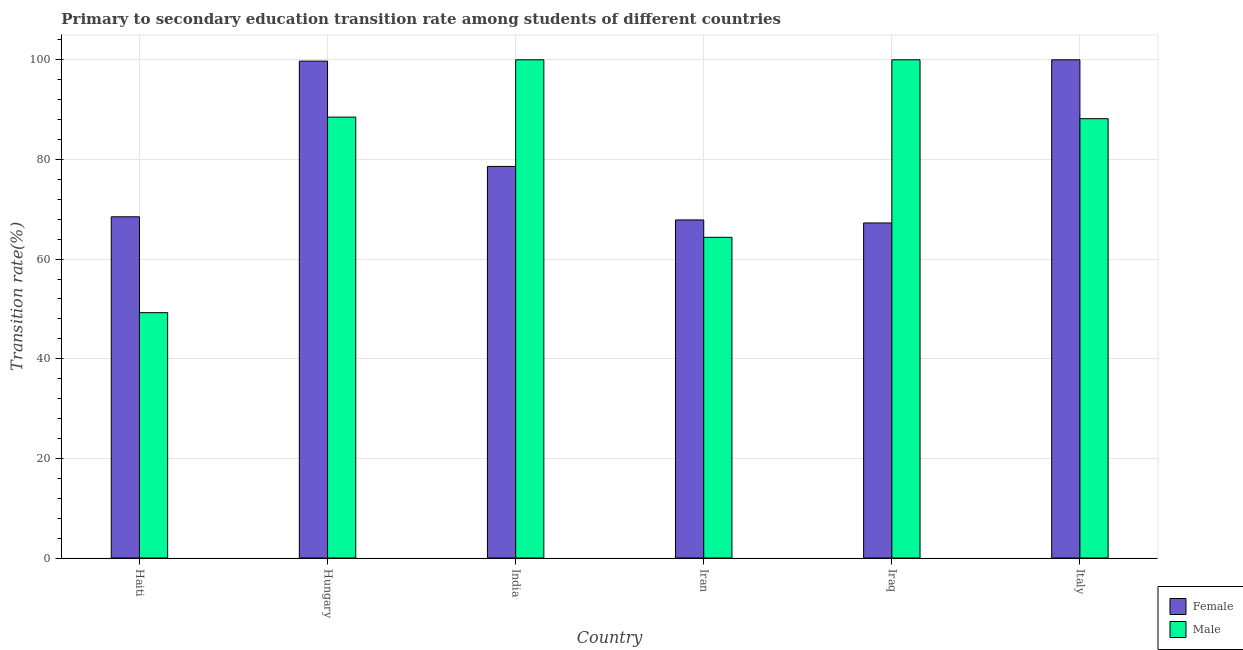How many different coloured bars are there?
Make the answer very short. 2. How many groups of bars are there?
Make the answer very short. 6. Are the number of bars per tick equal to the number of legend labels?
Your response must be concise. Yes. Are the number of bars on each tick of the X-axis equal?
Your response must be concise. Yes. What is the transition rate among male students in Hungary?
Offer a very short reply. 88.49. Across all countries, what is the minimum transition rate among male students?
Provide a short and direct response. 49.25. In which country was the transition rate among female students minimum?
Make the answer very short. Iraq. What is the total transition rate among male students in the graph?
Keep it short and to the point. 490.28. What is the difference between the transition rate among female students in Hungary and that in Iran?
Keep it short and to the point. 31.88. What is the difference between the transition rate among female students in Iran and the transition rate among male students in Italy?
Give a very brief answer. -20.32. What is the average transition rate among female students per country?
Give a very brief answer. 80.32. What is the difference between the transition rate among female students and transition rate among male students in Italy?
Provide a short and direct response. 11.82. What is the ratio of the transition rate among male students in Iran to that in Iraq?
Offer a terse response. 0.64. Is the transition rate among male students in Haiti less than that in Hungary?
Make the answer very short. Yes. Is the difference between the transition rate among male students in Haiti and India greater than the difference between the transition rate among female students in Haiti and India?
Provide a succinct answer. No. What is the difference between the highest and the second highest transition rate among female students?
Provide a short and direct response. 0.27. What is the difference between the highest and the lowest transition rate among female students?
Your answer should be compact. 32.75. In how many countries, is the transition rate among female students greater than the average transition rate among female students taken over all countries?
Offer a very short reply. 2. What does the 1st bar from the right in Iraq represents?
Provide a short and direct response. Male. How many bars are there?
Provide a succinct answer. 12. Are all the bars in the graph horizontal?
Your answer should be very brief. No. How many countries are there in the graph?
Give a very brief answer. 6. Does the graph contain any zero values?
Provide a short and direct response. No. Does the graph contain grids?
Provide a succinct answer. Yes. What is the title of the graph?
Ensure brevity in your answer.  Primary to secondary education transition rate among students of different countries. What is the label or title of the X-axis?
Your answer should be very brief. Country. What is the label or title of the Y-axis?
Offer a very short reply. Transition rate(%). What is the Transition rate(%) of Female in Haiti?
Provide a succinct answer. 68.48. What is the Transition rate(%) in Male in Haiti?
Keep it short and to the point. 49.25. What is the Transition rate(%) of Female in Hungary?
Offer a very short reply. 99.73. What is the Transition rate(%) of Male in Hungary?
Ensure brevity in your answer.  88.49. What is the Transition rate(%) in Female in India?
Your answer should be compact. 78.6. What is the Transition rate(%) of Male in India?
Ensure brevity in your answer.  100. What is the Transition rate(%) in Female in Iran?
Your answer should be very brief. 67.85. What is the Transition rate(%) of Male in Iran?
Give a very brief answer. 64.37. What is the Transition rate(%) of Female in Iraq?
Offer a very short reply. 67.25. What is the Transition rate(%) of Female in Italy?
Your response must be concise. 100. What is the Transition rate(%) in Male in Italy?
Ensure brevity in your answer.  88.18. Across all countries, what is the maximum Transition rate(%) of Female?
Keep it short and to the point. 100. Across all countries, what is the maximum Transition rate(%) in Male?
Provide a succinct answer. 100. Across all countries, what is the minimum Transition rate(%) in Female?
Keep it short and to the point. 67.25. Across all countries, what is the minimum Transition rate(%) of Male?
Your answer should be very brief. 49.25. What is the total Transition rate(%) of Female in the graph?
Provide a succinct answer. 481.91. What is the total Transition rate(%) in Male in the graph?
Offer a terse response. 490.28. What is the difference between the Transition rate(%) of Female in Haiti and that in Hungary?
Your answer should be compact. -31.24. What is the difference between the Transition rate(%) of Male in Haiti and that in Hungary?
Provide a succinct answer. -39.25. What is the difference between the Transition rate(%) of Female in Haiti and that in India?
Ensure brevity in your answer.  -10.11. What is the difference between the Transition rate(%) in Male in Haiti and that in India?
Make the answer very short. -50.75. What is the difference between the Transition rate(%) in Female in Haiti and that in Iran?
Make the answer very short. 0.63. What is the difference between the Transition rate(%) of Male in Haiti and that in Iran?
Offer a terse response. -15.12. What is the difference between the Transition rate(%) of Female in Haiti and that in Iraq?
Offer a terse response. 1.24. What is the difference between the Transition rate(%) of Male in Haiti and that in Iraq?
Provide a short and direct response. -50.75. What is the difference between the Transition rate(%) of Female in Haiti and that in Italy?
Your answer should be very brief. -31.52. What is the difference between the Transition rate(%) of Male in Haiti and that in Italy?
Make the answer very short. -38.93. What is the difference between the Transition rate(%) of Female in Hungary and that in India?
Your answer should be compact. 21.13. What is the difference between the Transition rate(%) of Male in Hungary and that in India?
Keep it short and to the point. -11.51. What is the difference between the Transition rate(%) in Female in Hungary and that in Iran?
Give a very brief answer. 31.88. What is the difference between the Transition rate(%) in Male in Hungary and that in Iran?
Offer a very short reply. 24.13. What is the difference between the Transition rate(%) in Female in Hungary and that in Iraq?
Your answer should be very brief. 32.48. What is the difference between the Transition rate(%) in Male in Hungary and that in Iraq?
Ensure brevity in your answer.  -11.51. What is the difference between the Transition rate(%) of Female in Hungary and that in Italy?
Offer a terse response. -0.27. What is the difference between the Transition rate(%) of Male in Hungary and that in Italy?
Your answer should be compact. 0.32. What is the difference between the Transition rate(%) in Female in India and that in Iran?
Offer a very short reply. 10.74. What is the difference between the Transition rate(%) in Male in India and that in Iran?
Your response must be concise. 35.63. What is the difference between the Transition rate(%) in Female in India and that in Iraq?
Ensure brevity in your answer.  11.35. What is the difference between the Transition rate(%) in Male in India and that in Iraq?
Make the answer very short. 0. What is the difference between the Transition rate(%) of Female in India and that in Italy?
Give a very brief answer. -21.4. What is the difference between the Transition rate(%) of Male in India and that in Italy?
Ensure brevity in your answer.  11.82. What is the difference between the Transition rate(%) of Female in Iran and that in Iraq?
Your response must be concise. 0.6. What is the difference between the Transition rate(%) in Male in Iran and that in Iraq?
Keep it short and to the point. -35.63. What is the difference between the Transition rate(%) in Female in Iran and that in Italy?
Your answer should be very brief. -32.15. What is the difference between the Transition rate(%) in Male in Iran and that in Italy?
Your answer should be very brief. -23.81. What is the difference between the Transition rate(%) in Female in Iraq and that in Italy?
Your answer should be very brief. -32.75. What is the difference between the Transition rate(%) in Male in Iraq and that in Italy?
Make the answer very short. 11.82. What is the difference between the Transition rate(%) in Female in Haiti and the Transition rate(%) in Male in Hungary?
Give a very brief answer. -20.01. What is the difference between the Transition rate(%) of Female in Haiti and the Transition rate(%) of Male in India?
Give a very brief answer. -31.52. What is the difference between the Transition rate(%) of Female in Haiti and the Transition rate(%) of Male in Iran?
Provide a succinct answer. 4.12. What is the difference between the Transition rate(%) in Female in Haiti and the Transition rate(%) in Male in Iraq?
Offer a very short reply. -31.52. What is the difference between the Transition rate(%) in Female in Haiti and the Transition rate(%) in Male in Italy?
Ensure brevity in your answer.  -19.69. What is the difference between the Transition rate(%) of Female in Hungary and the Transition rate(%) of Male in India?
Offer a very short reply. -0.27. What is the difference between the Transition rate(%) in Female in Hungary and the Transition rate(%) in Male in Iran?
Your answer should be compact. 35.36. What is the difference between the Transition rate(%) of Female in Hungary and the Transition rate(%) of Male in Iraq?
Give a very brief answer. -0.27. What is the difference between the Transition rate(%) in Female in Hungary and the Transition rate(%) in Male in Italy?
Keep it short and to the point. 11.55. What is the difference between the Transition rate(%) of Female in India and the Transition rate(%) of Male in Iran?
Give a very brief answer. 14.23. What is the difference between the Transition rate(%) in Female in India and the Transition rate(%) in Male in Iraq?
Ensure brevity in your answer.  -21.4. What is the difference between the Transition rate(%) in Female in India and the Transition rate(%) in Male in Italy?
Ensure brevity in your answer.  -9.58. What is the difference between the Transition rate(%) in Female in Iran and the Transition rate(%) in Male in Iraq?
Ensure brevity in your answer.  -32.15. What is the difference between the Transition rate(%) of Female in Iran and the Transition rate(%) of Male in Italy?
Provide a short and direct response. -20.32. What is the difference between the Transition rate(%) of Female in Iraq and the Transition rate(%) of Male in Italy?
Offer a terse response. -20.93. What is the average Transition rate(%) in Female per country?
Provide a short and direct response. 80.32. What is the average Transition rate(%) of Male per country?
Your answer should be compact. 81.71. What is the difference between the Transition rate(%) of Female and Transition rate(%) of Male in Haiti?
Make the answer very short. 19.24. What is the difference between the Transition rate(%) in Female and Transition rate(%) in Male in Hungary?
Give a very brief answer. 11.23. What is the difference between the Transition rate(%) in Female and Transition rate(%) in Male in India?
Offer a terse response. -21.4. What is the difference between the Transition rate(%) in Female and Transition rate(%) in Male in Iran?
Ensure brevity in your answer.  3.49. What is the difference between the Transition rate(%) of Female and Transition rate(%) of Male in Iraq?
Offer a terse response. -32.75. What is the difference between the Transition rate(%) of Female and Transition rate(%) of Male in Italy?
Give a very brief answer. 11.82. What is the ratio of the Transition rate(%) in Female in Haiti to that in Hungary?
Give a very brief answer. 0.69. What is the ratio of the Transition rate(%) of Male in Haiti to that in Hungary?
Ensure brevity in your answer.  0.56. What is the ratio of the Transition rate(%) of Female in Haiti to that in India?
Ensure brevity in your answer.  0.87. What is the ratio of the Transition rate(%) of Male in Haiti to that in India?
Ensure brevity in your answer.  0.49. What is the ratio of the Transition rate(%) in Female in Haiti to that in Iran?
Provide a short and direct response. 1.01. What is the ratio of the Transition rate(%) of Male in Haiti to that in Iran?
Give a very brief answer. 0.77. What is the ratio of the Transition rate(%) of Female in Haiti to that in Iraq?
Make the answer very short. 1.02. What is the ratio of the Transition rate(%) of Male in Haiti to that in Iraq?
Provide a short and direct response. 0.49. What is the ratio of the Transition rate(%) of Female in Haiti to that in Italy?
Offer a terse response. 0.68. What is the ratio of the Transition rate(%) in Male in Haiti to that in Italy?
Offer a very short reply. 0.56. What is the ratio of the Transition rate(%) in Female in Hungary to that in India?
Keep it short and to the point. 1.27. What is the ratio of the Transition rate(%) of Male in Hungary to that in India?
Make the answer very short. 0.88. What is the ratio of the Transition rate(%) in Female in Hungary to that in Iran?
Your response must be concise. 1.47. What is the ratio of the Transition rate(%) of Male in Hungary to that in Iran?
Ensure brevity in your answer.  1.37. What is the ratio of the Transition rate(%) in Female in Hungary to that in Iraq?
Give a very brief answer. 1.48. What is the ratio of the Transition rate(%) of Male in Hungary to that in Iraq?
Offer a terse response. 0.88. What is the ratio of the Transition rate(%) in Female in Hungary to that in Italy?
Provide a short and direct response. 1. What is the ratio of the Transition rate(%) of Female in India to that in Iran?
Give a very brief answer. 1.16. What is the ratio of the Transition rate(%) in Male in India to that in Iran?
Ensure brevity in your answer.  1.55. What is the ratio of the Transition rate(%) in Female in India to that in Iraq?
Make the answer very short. 1.17. What is the ratio of the Transition rate(%) of Female in India to that in Italy?
Your answer should be very brief. 0.79. What is the ratio of the Transition rate(%) in Male in India to that in Italy?
Your answer should be very brief. 1.13. What is the ratio of the Transition rate(%) of Male in Iran to that in Iraq?
Offer a very short reply. 0.64. What is the ratio of the Transition rate(%) in Female in Iran to that in Italy?
Your response must be concise. 0.68. What is the ratio of the Transition rate(%) in Male in Iran to that in Italy?
Your answer should be very brief. 0.73. What is the ratio of the Transition rate(%) in Female in Iraq to that in Italy?
Provide a short and direct response. 0.67. What is the ratio of the Transition rate(%) in Male in Iraq to that in Italy?
Your answer should be compact. 1.13. What is the difference between the highest and the second highest Transition rate(%) of Female?
Give a very brief answer. 0.27. What is the difference between the highest and the lowest Transition rate(%) in Female?
Keep it short and to the point. 32.75. What is the difference between the highest and the lowest Transition rate(%) of Male?
Provide a short and direct response. 50.75. 